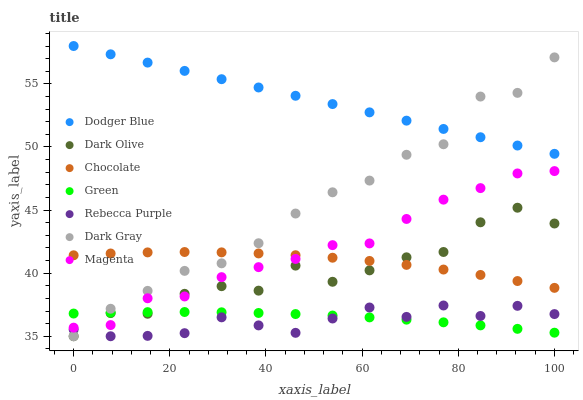Does Rebecca Purple have the minimum area under the curve?
Answer yes or no. Yes. Does Dodger Blue have the maximum area under the curve?
Answer yes or no. Yes. Does Chocolate have the minimum area under the curve?
Answer yes or no. No. Does Chocolate have the maximum area under the curve?
Answer yes or no. No. Is Dodger Blue the smoothest?
Answer yes or no. Yes. Is Dark Olive the roughest?
Answer yes or no. Yes. Is Chocolate the smoothest?
Answer yes or no. No. Is Chocolate the roughest?
Answer yes or no. No. Does Dark Olive have the lowest value?
Answer yes or no. Yes. Does Chocolate have the lowest value?
Answer yes or no. No. Does Dodger Blue have the highest value?
Answer yes or no. Yes. Does Chocolate have the highest value?
Answer yes or no. No. Is Rebecca Purple less than Magenta?
Answer yes or no. Yes. Is Dodger Blue greater than Rebecca Purple?
Answer yes or no. Yes. Does Dark Gray intersect Green?
Answer yes or no. Yes. Is Dark Gray less than Green?
Answer yes or no. No. Is Dark Gray greater than Green?
Answer yes or no. No. Does Rebecca Purple intersect Magenta?
Answer yes or no. No. 